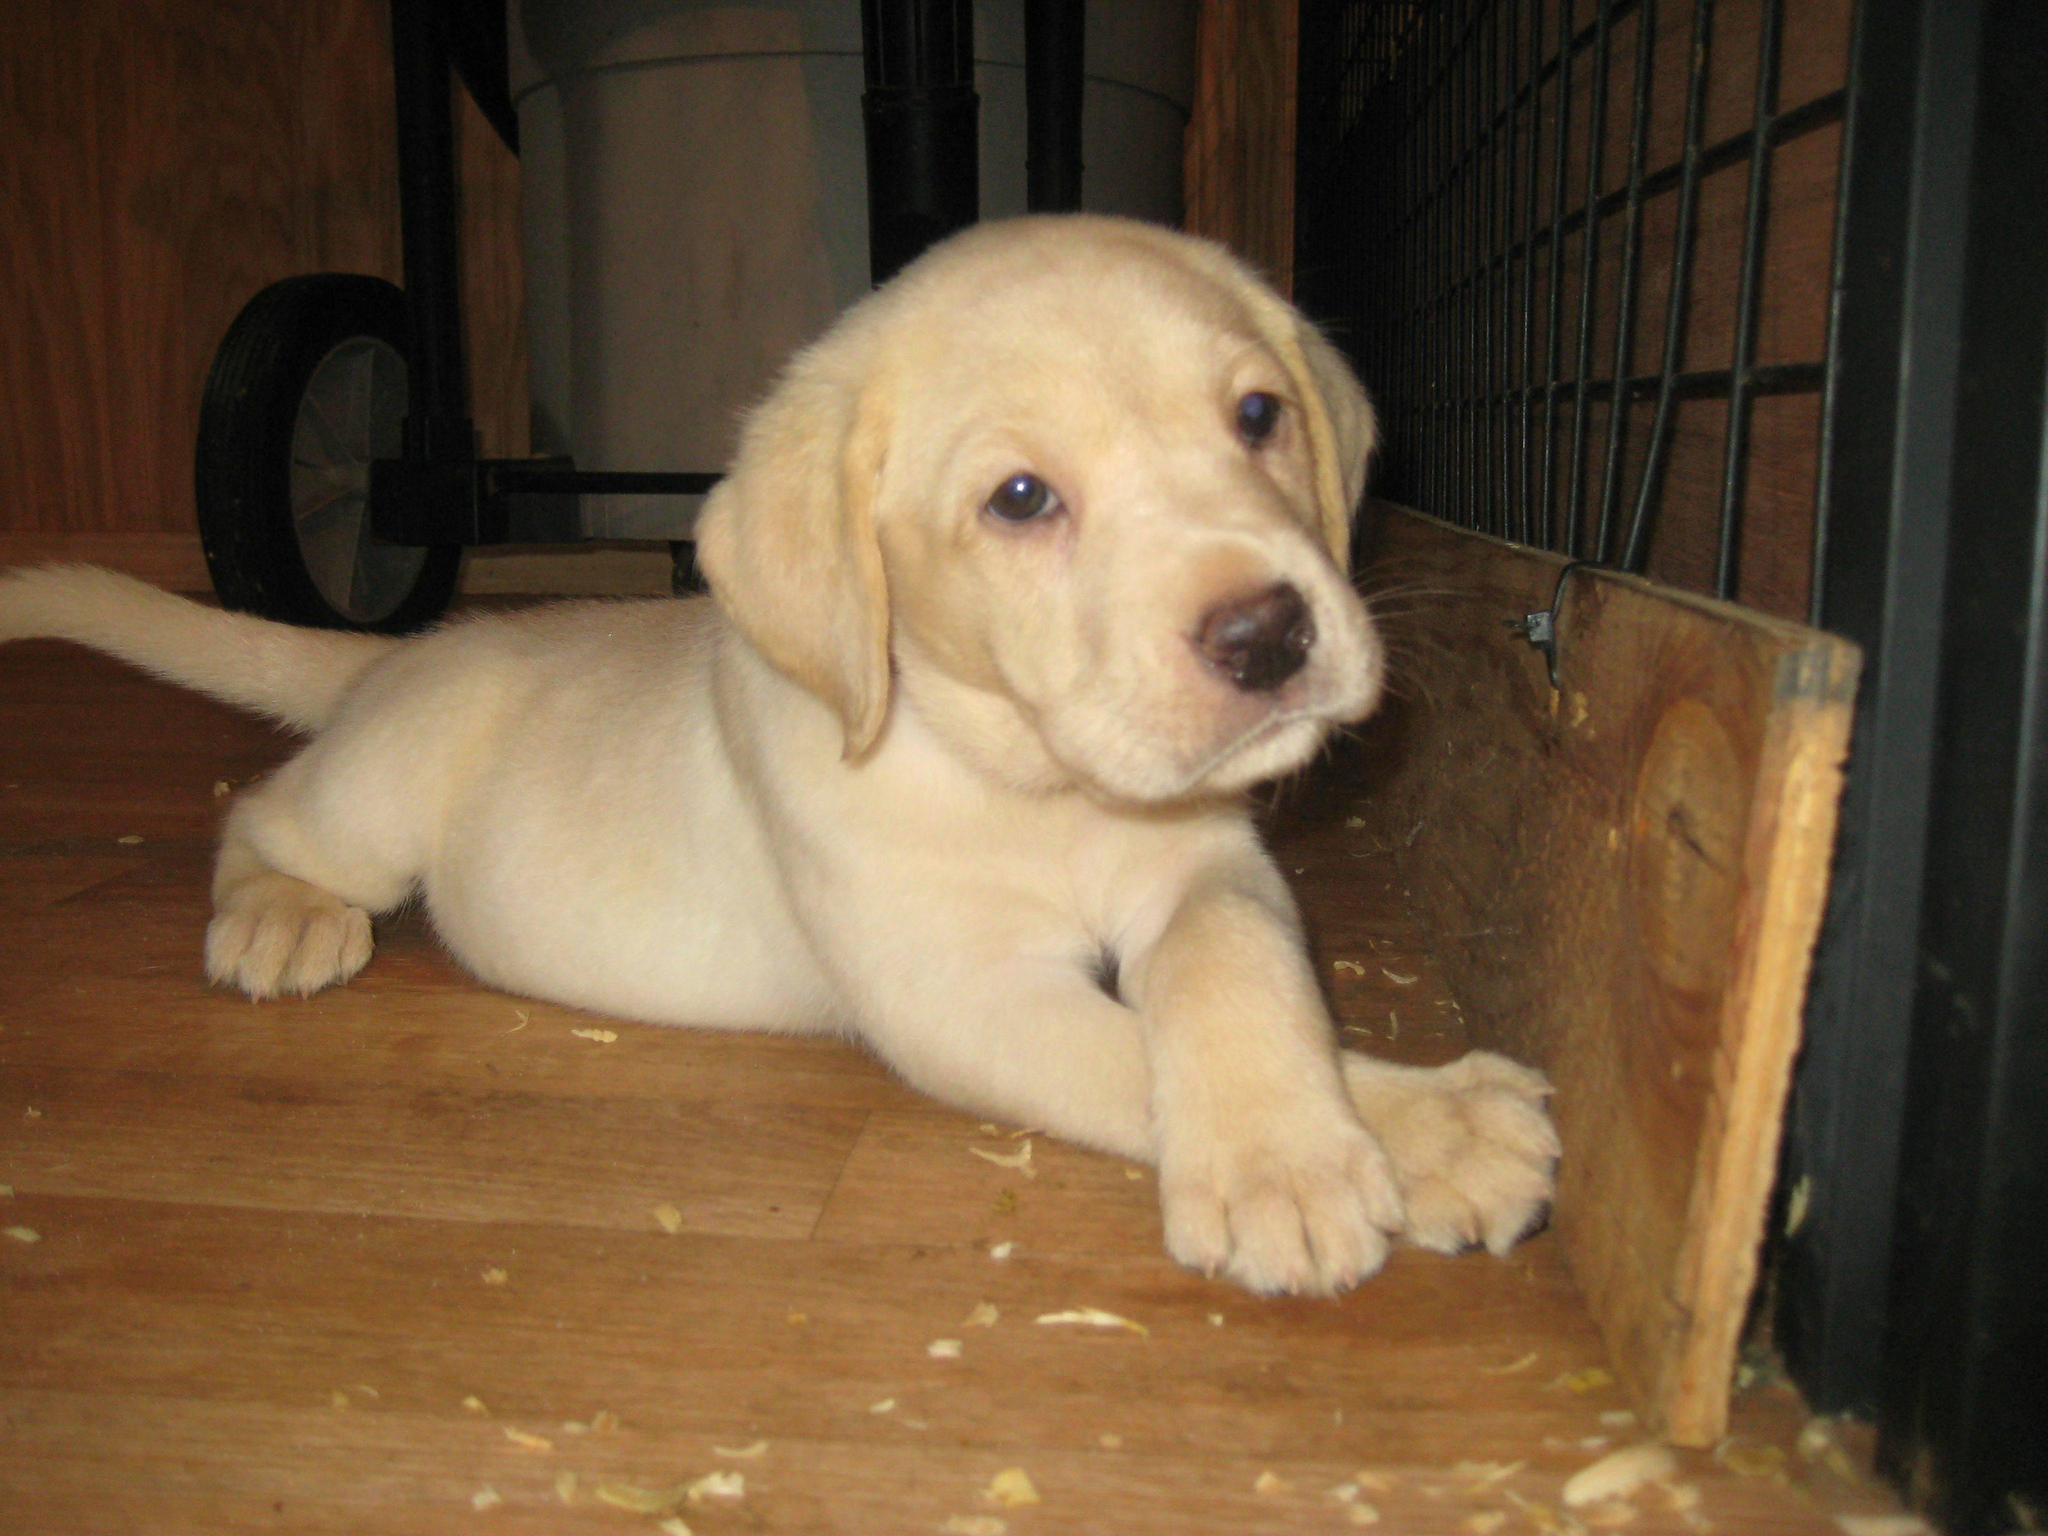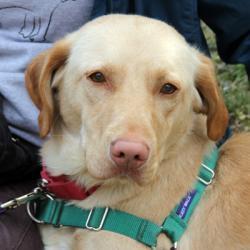The first image is the image on the left, the second image is the image on the right. For the images displayed, is the sentence "The left image contains one dog laying on wooden flooring." factually correct? Answer yes or no. Yes. The first image is the image on the left, the second image is the image on the right. For the images shown, is this caption "Each image contains one dog, and every dog is a """"blond"""" puppy." true? Answer yes or no. No. 